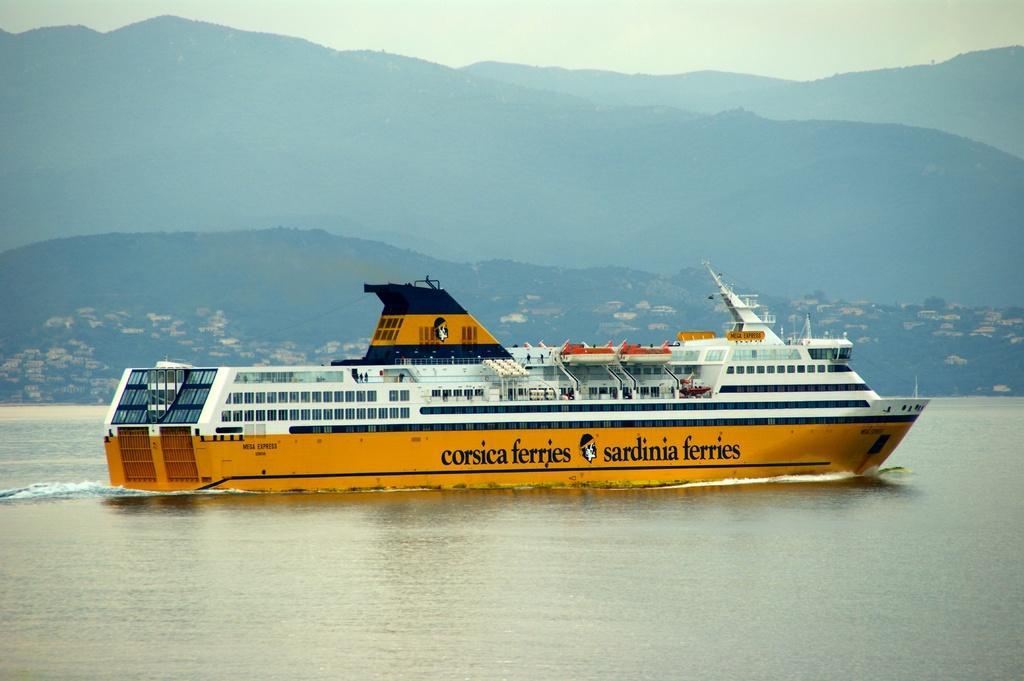In one or two sentences, can you explain what this image depicts? There is water. Also there is a ship with windows on the water. And something is written on the ship. In the background there are hills and sky. 